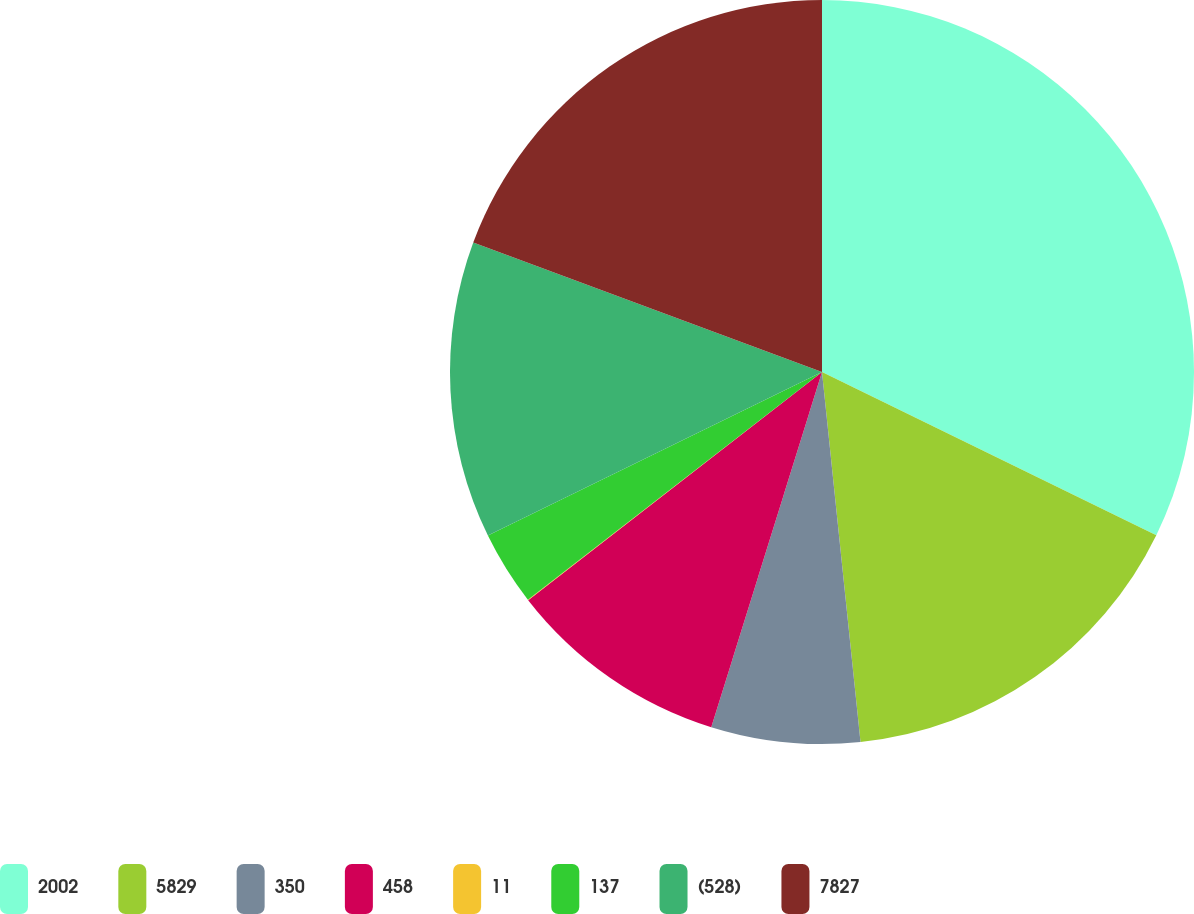Convert chart to OTSL. <chart><loc_0><loc_0><loc_500><loc_500><pie_chart><fcel>2002<fcel>5829<fcel>350<fcel>458<fcel>11<fcel>137<fcel>(528)<fcel>7827<nl><fcel>32.22%<fcel>16.12%<fcel>6.46%<fcel>9.68%<fcel>0.02%<fcel>3.24%<fcel>12.9%<fcel>19.34%<nl></chart> 